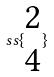Convert formula to latex. <formula><loc_0><loc_0><loc_500><loc_500>s s \{ \begin{matrix} 2 \\ 4 \end{matrix} \}</formula> 